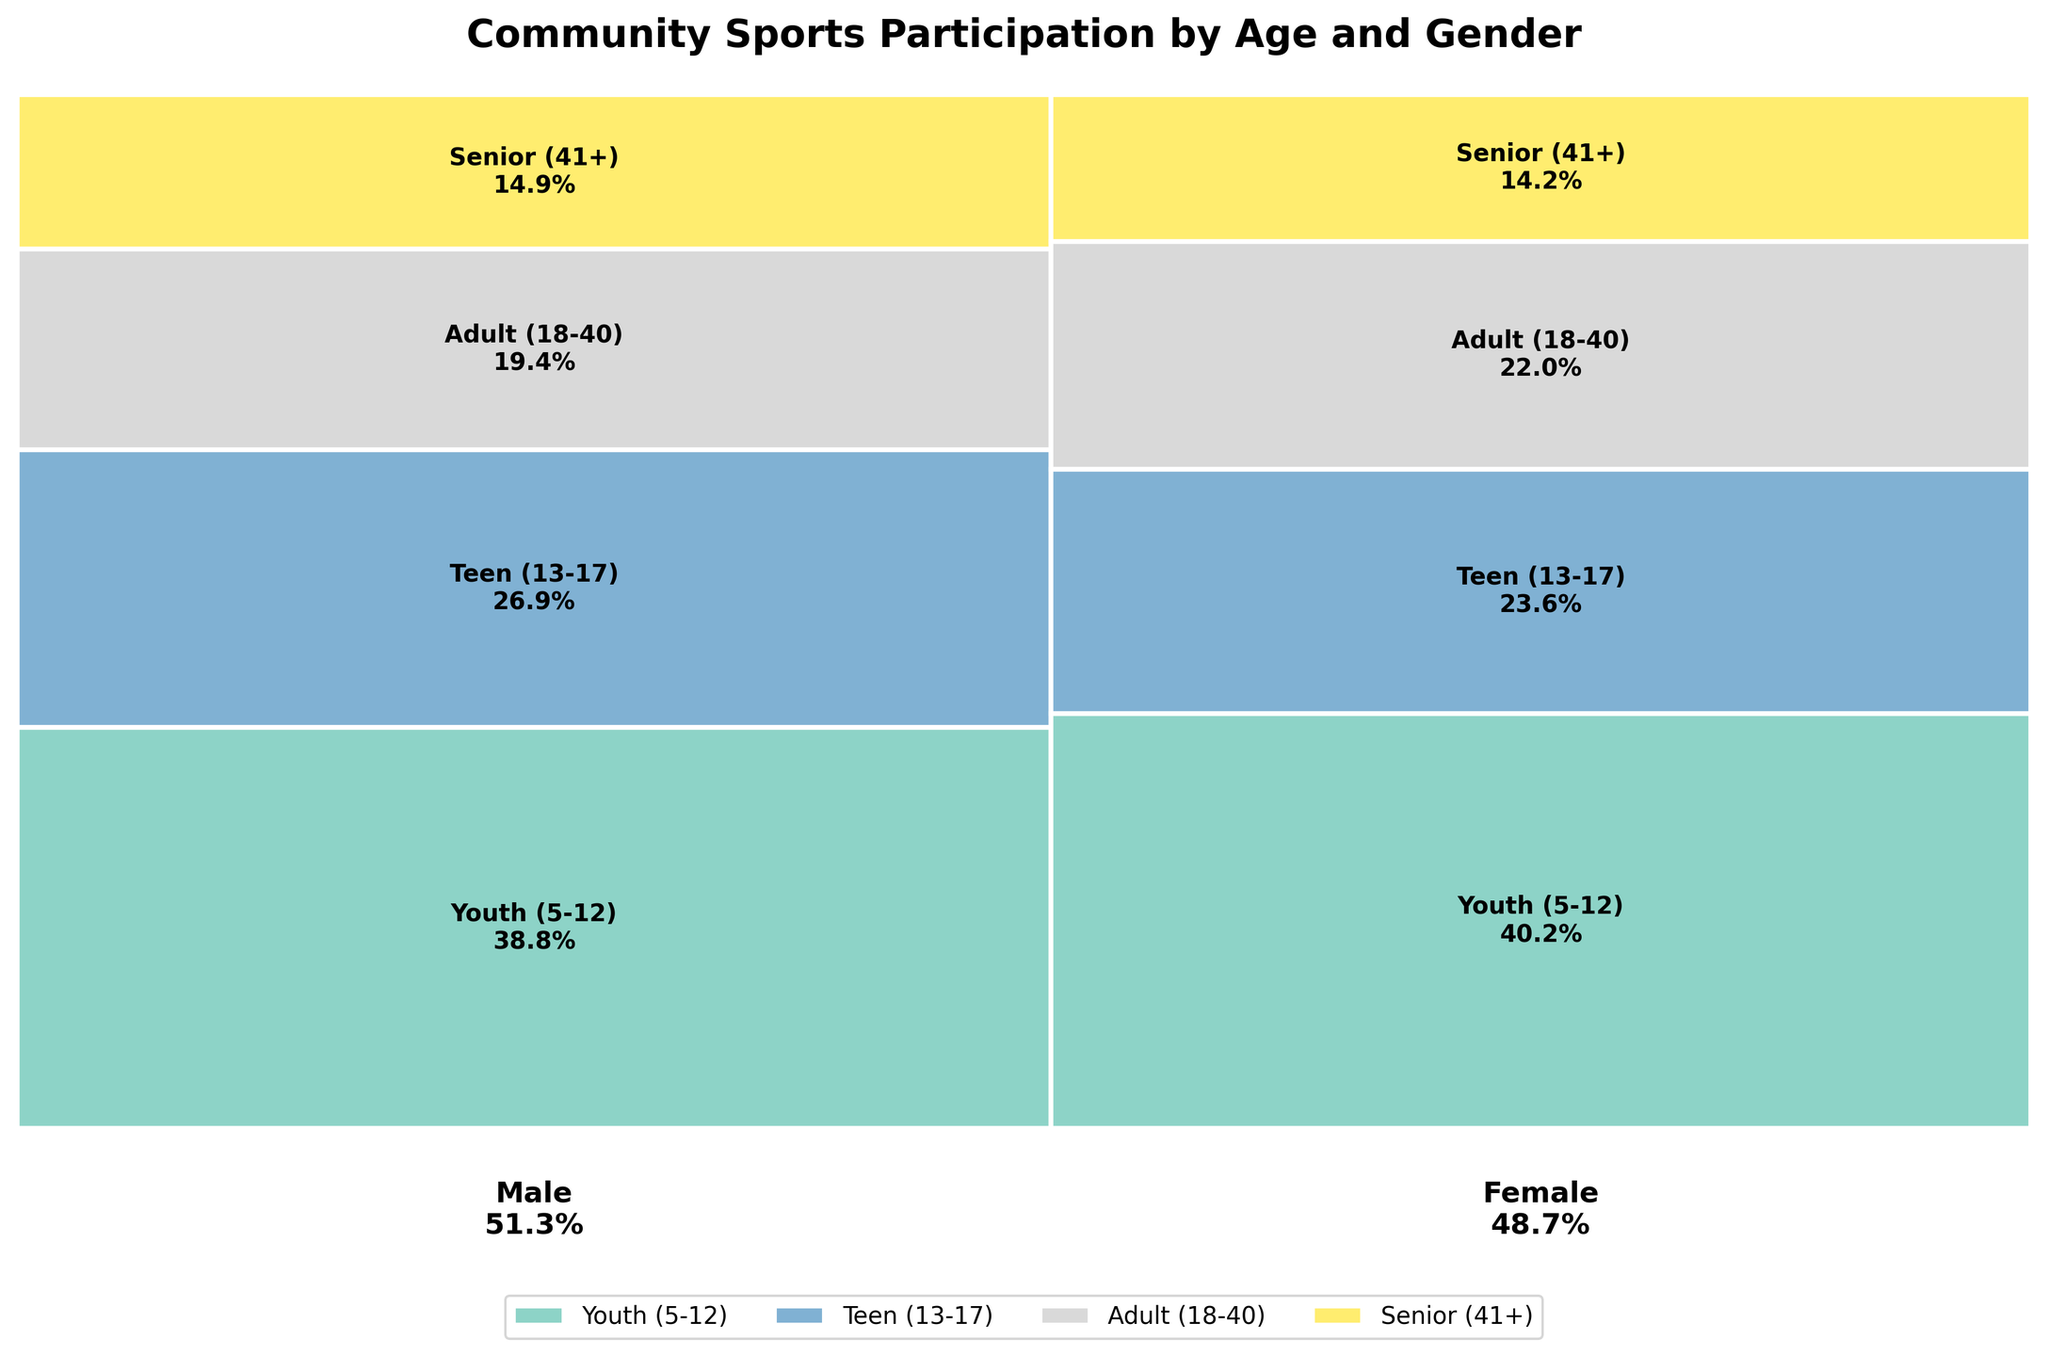What is the title of the mosaic plot? The title of a chart is generally placed at the top, indicating what the chart represents. In this case, the provided code sets the title of the plot to "Community Sports Participation by Age and Gender".
Answer: Community Sports Participation by Age and Gender Which gender has a higher overall participation rate? In the mosaic plot, the width of the bars for each gender indicates their overall participation rate. The gender with the wider bar has a higher participation rate.
Answer: Male What age group has the largest participation percentage for males? The height of each colored section within the male bar represents the participation percentage for each age group. The tallest section for males indicates the largest participation percentage.
Answer: Youth (5-12) Compare participation rates: Are there more females participating in Volleyball or males in Soccer? To compare these rates, look at the height percentages of the Volleyball section in the female bar and the Soccer section in the male bar. The taller section indicates a higher rate.
Answer: Females in Volleyball Which age group has the smallest participation percentage for females? To determine the smallest participation percentage for females, observe the colored sections in the female bar and identify the shortest one.
Answer: Senior (41+) How does participation in basketball compare between teens and adults? For this, compare the heights of the sections labeled Basketball within the teen and adult age groups for both genders combined. You need to add the heights for each gender to get a combined height for each age group.
Answer: Teens have higher participation in Basketball Which sport has the most consistent participation rate across all ages for females? Identify which sport has relatively uniform height sections within the female bar across different age groups.
Answer: Swimming Is there a significant difference in participation rates for Tennis between males and females? Look at the Tennis sections' heights within both the male and female bars. If the heights are similar, there is no significant difference; otherwise, there is.
Answer: No significant difference What is the least popular sport among seniors (41+) for both genders combined? To find the least popular sport among seniors for both genders combined, look at the smallest height of the sections labeled by sports within the Senior (41+) age group in the plot.
Answer: Bowling Compare the participation rates in soccer for youth and teens. To compare these rates, observe the heights of the sections labeled Soccer within the Youth (5-12) and Teen (13-17) age groups across both genders.
Answer: Youth (5-12) has higher participation 